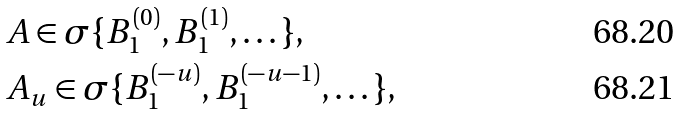Convert formula to latex. <formula><loc_0><loc_0><loc_500><loc_500>& A \in \sigma \{ B _ { 1 } ^ { ( 0 ) } , B _ { 1 } ^ { ( 1 ) } , \dots \} , \\ & A _ { u } \in \sigma \{ B _ { 1 } ^ { ( - u ) } , B _ { 1 } ^ { ( - u - 1 ) } , \dots \} ,</formula> 